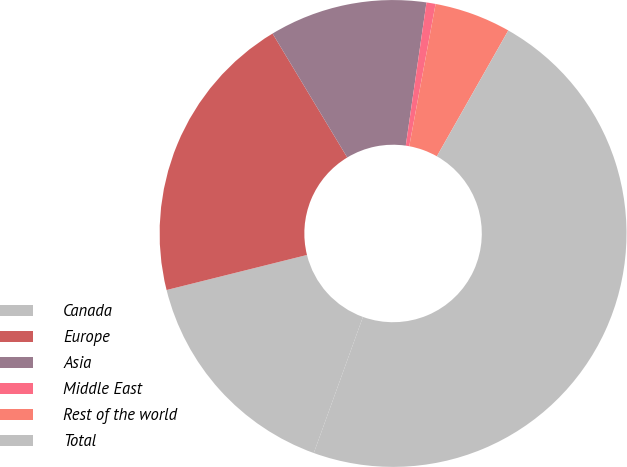Convert chart to OTSL. <chart><loc_0><loc_0><loc_500><loc_500><pie_chart><fcel>Canada<fcel>Europe<fcel>Asia<fcel>Middle East<fcel>Rest of the world<fcel>Total<nl><fcel>15.59%<fcel>20.26%<fcel>10.92%<fcel>0.63%<fcel>5.3%<fcel>47.3%<nl></chart> 